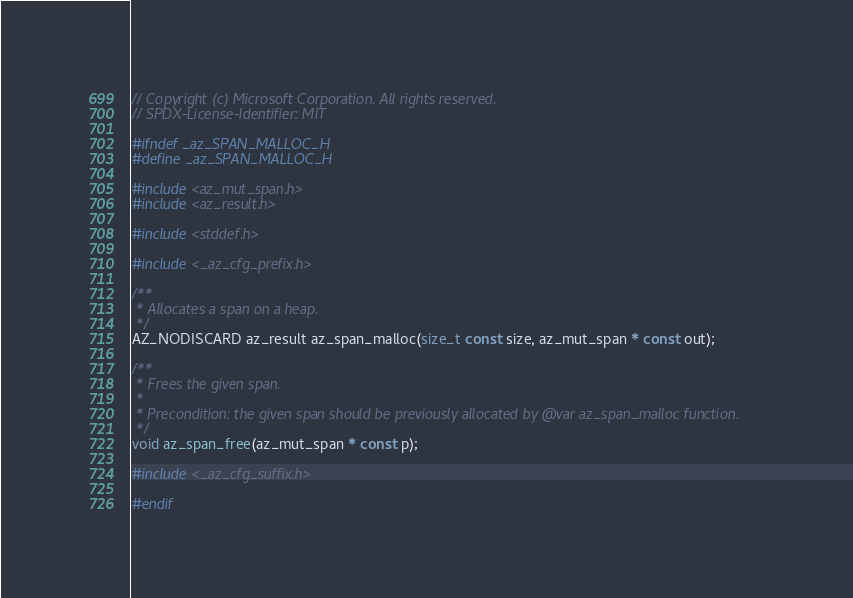Convert code to text. <code><loc_0><loc_0><loc_500><loc_500><_C_>// Copyright (c) Microsoft Corporation. All rights reserved.
// SPDX-License-Identifier: MIT

#ifndef _az_SPAN_MALLOC_H
#define _az_SPAN_MALLOC_H

#include <az_mut_span.h>
#include <az_result.h>

#include <stddef.h>

#include <_az_cfg_prefix.h>

/**
 * Allocates a span on a heap.
 */
AZ_NODISCARD az_result az_span_malloc(size_t const size, az_mut_span * const out);

/**
 * Frees the given span.
 *
 * Precondition: the given span should be previously allocated by @var az_span_malloc function.
 */
void az_span_free(az_mut_span * const p);

#include <_az_cfg_suffix.h>

#endif
</code> 